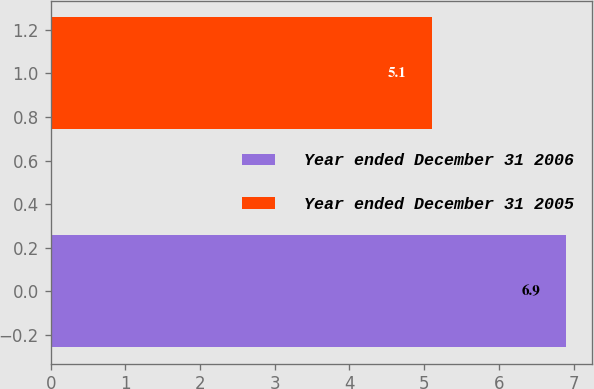Convert chart. <chart><loc_0><loc_0><loc_500><loc_500><bar_chart><fcel>Year ended December 31 2006<fcel>Year ended December 31 2005<nl><fcel>6.9<fcel>5.1<nl></chart> 